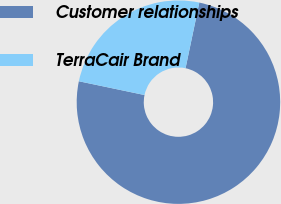Convert chart. <chart><loc_0><loc_0><loc_500><loc_500><pie_chart><fcel>Customer relationships<fcel>TerraCair Brand<nl><fcel>75.0%<fcel>25.0%<nl></chart> 